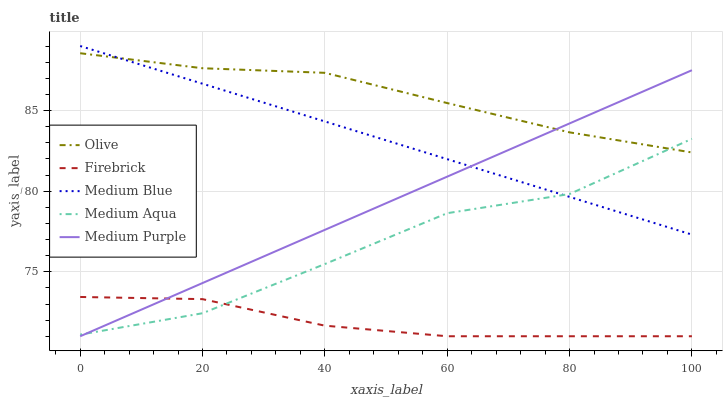Does Firebrick have the minimum area under the curve?
Answer yes or no. Yes. Does Olive have the maximum area under the curve?
Answer yes or no. Yes. Does Medium Aqua have the minimum area under the curve?
Answer yes or no. No. Does Medium Aqua have the maximum area under the curve?
Answer yes or no. No. Is Medium Blue the smoothest?
Answer yes or no. Yes. Is Medium Aqua the roughest?
Answer yes or no. Yes. Is Firebrick the smoothest?
Answer yes or no. No. Is Firebrick the roughest?
Answer yes or no. No. Does Firebrick have the lowest value?
Answer yes or no. Yes. Does Medium Aqua have the lowest value?
Answer yes or no. No. Does Medium Blue have the highest value?
Answer yes or no. Yes. Does Medium Aqua have the highest value?
Answer yes or no. No. Is Firebrick less than Medium Blue?
Answer yes or no. Yes. Is Olive greater than Firebrick?
Answer yes or no. Yes. Does Olive intersect Medium Blue?
Answer yes or no. Yes. Is Olive less than Medium Blue?
Answer yes or no. No. Is Olive greater than Medium Blue?
Answer yes or no. No. Does Firebrick intersect Medium Blue?
Answer yes or no. No. 